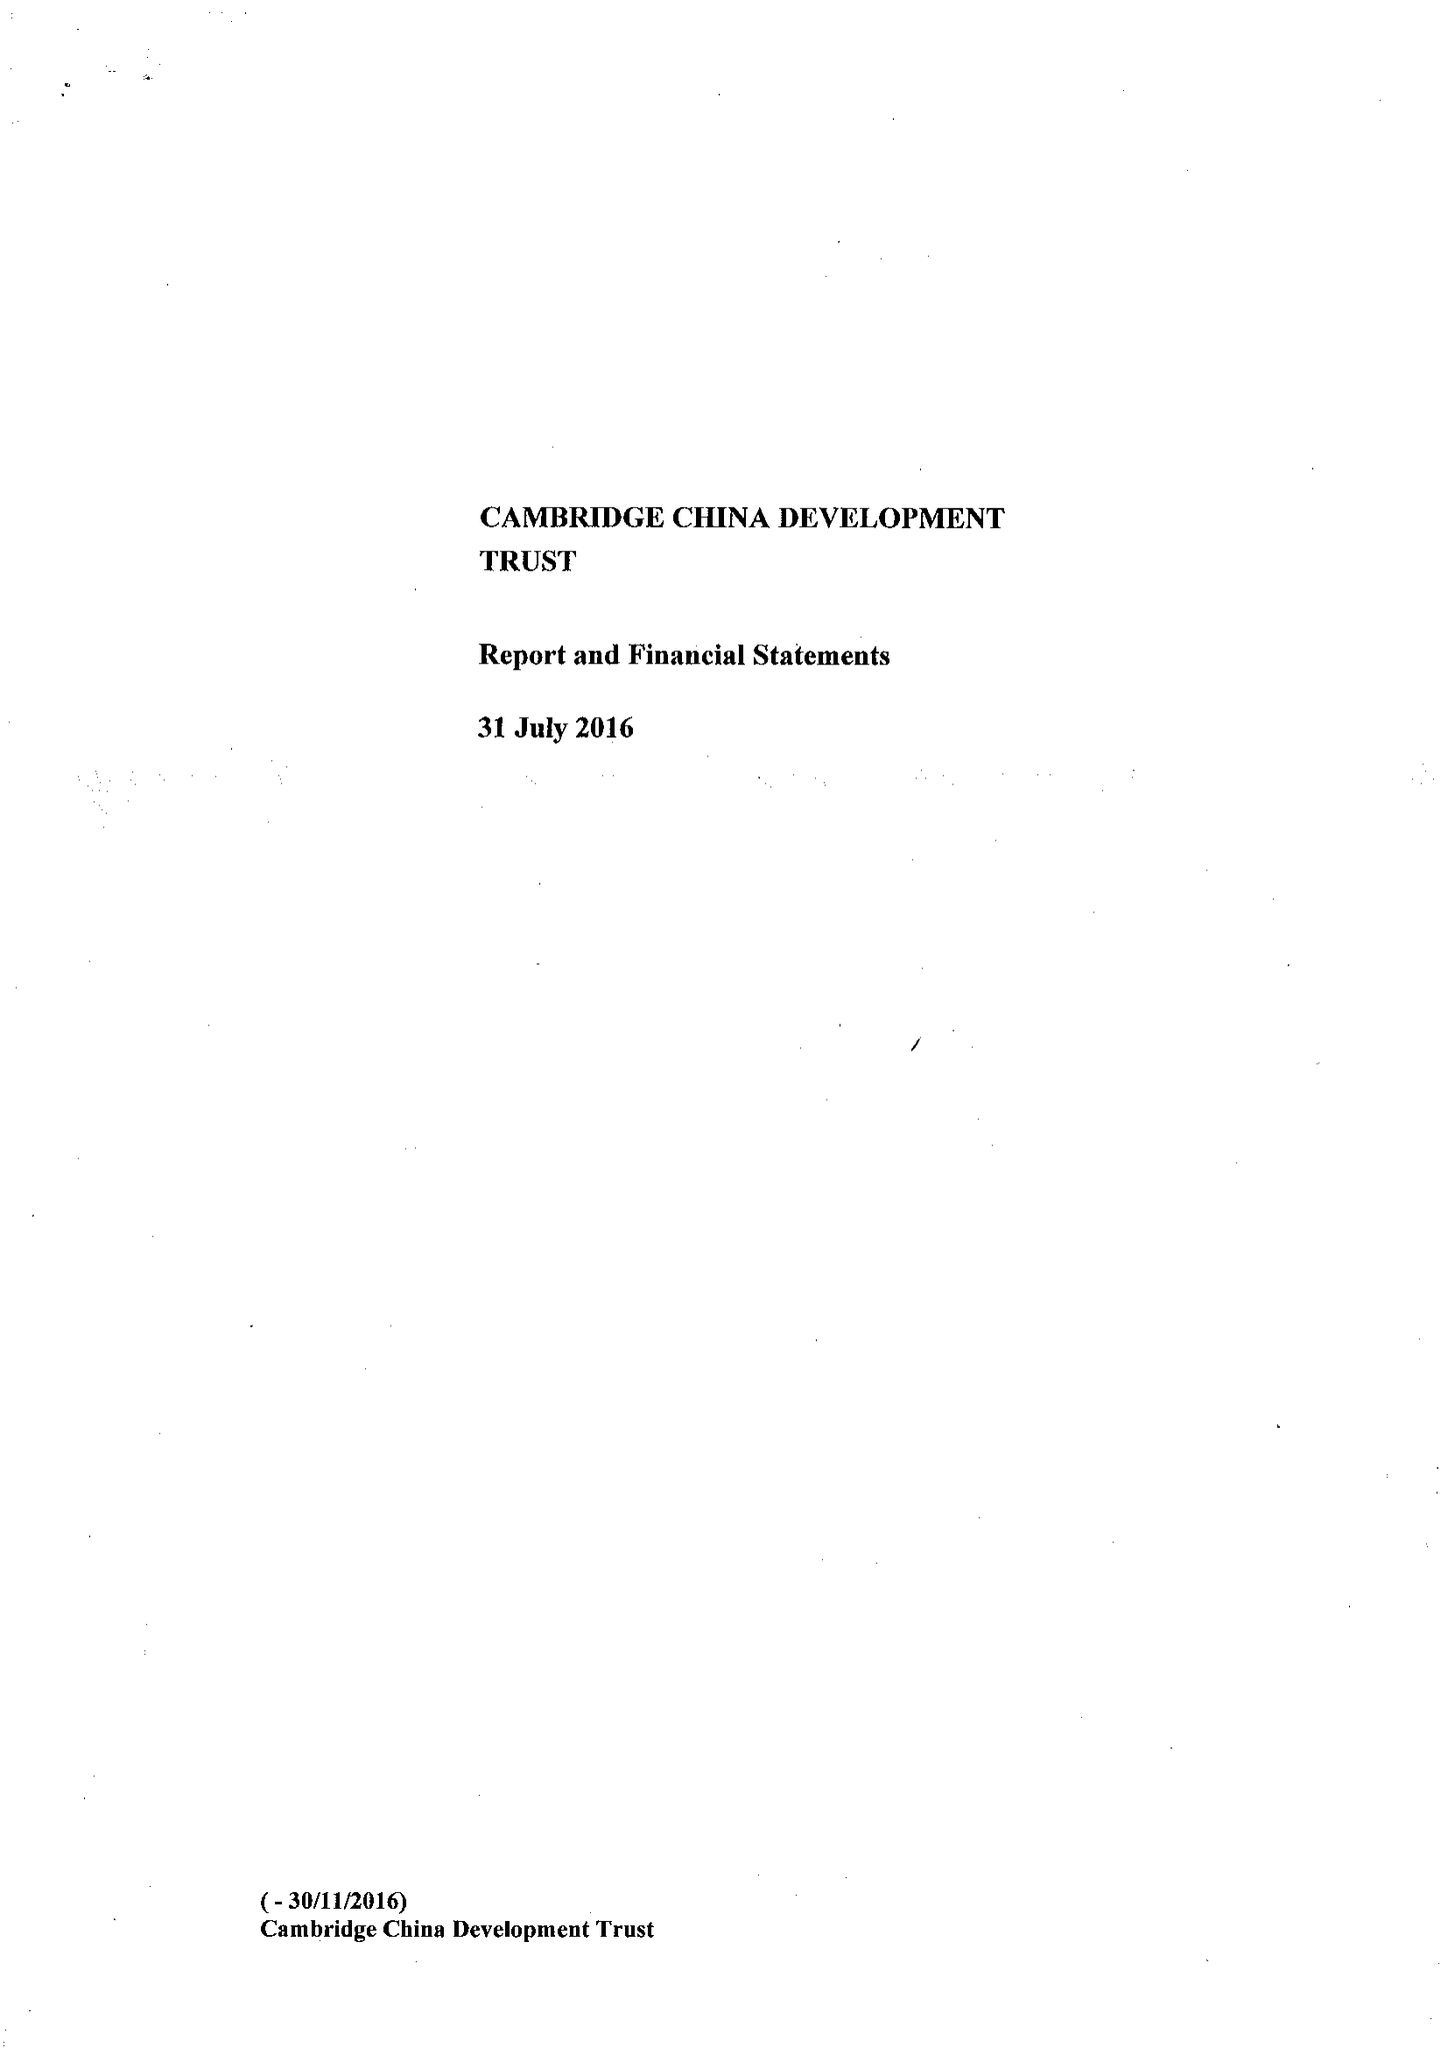What is the value for the address__street_line?
Answer the question using a single word or phrase. None 